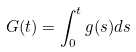Convert formula to latex. <formula><loc_0><loc_0><loc_500><loc_500>G ( t ) = \int _ { 0 } ^ { t } g ( s ) d s</formula> 